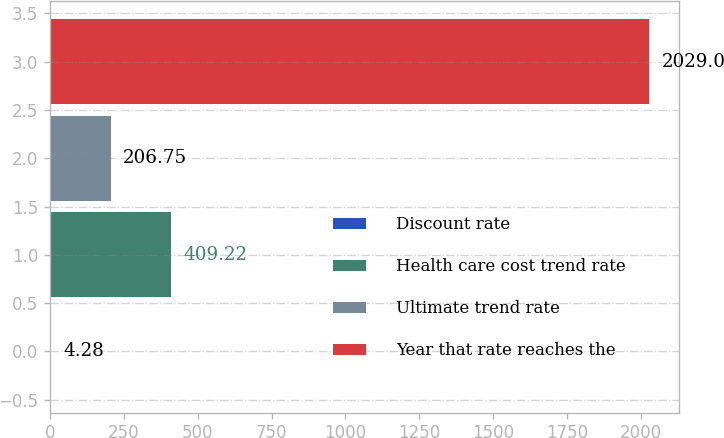Convert chart to OTSL. <chart><loc_0><loc_0><loc_500><loc_500><bar_chart><fcel>Discount rate<fcel>Health care cost trend rate<fcel>Ultimate trend rate<fcel>Year that rate reaches the<nl><fcel>4.28<fcel>409.22<fcel>206.75<fcel>2029<nl></chart> 